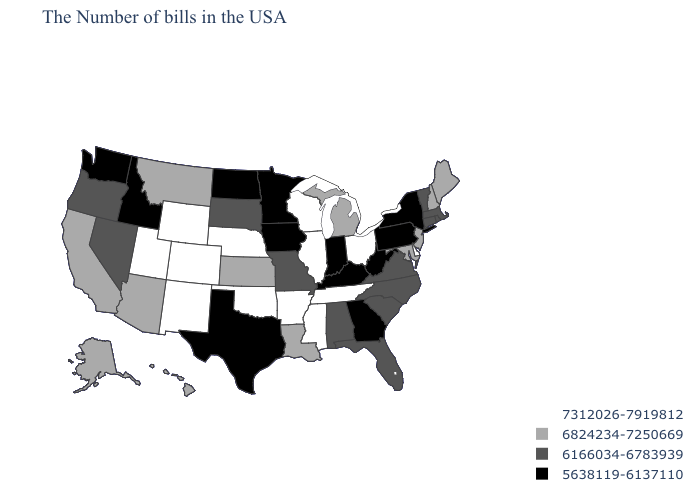What is the value of Kansas?
Short answer required. 6824234-7250669. Which states hav the highest value in the MidWest?
Write a very short answer. Ohio, Wisconsin, Illinois, Nebraska. Does Colorado have the highest value in the USA?
Keep it brief. Yes. Does Florida have the same value as New Jersey?
Keep it brief. No. What is the lowest value in the USA?
Quick response, please. 5638119-6137110. What is the highest value in the West ?
Quick response, please. 7312026-7919812. What is the highest value in the USA?
Quick response, please. 7312026-7919812. What is the value of South Dakota?
Give a very brief answer. 6166034-6783939. What is the value of Alabama?
Answer briefly. 6166034-6783939. Does Illinois have the highest value in the MidWest?
Give a very brief answer. Yes. Name the states that have a value in the range 6166034-6783939?
Give a very brief answer. Massachusetts, Rhode Island, Vermont, Connecticut, Virginia, North Carolina, South Carolina, Florida, Alabama, Missouri, South Dakota, Nevada, Oregon. What is the highest value in the West ?
Quick response, please. 7312026-7919812. Does Colorado have the same value as Missouri?
Answer briefly. No. What is the highest value in the Northeast ?
Keep it brief. 6824234-7250669. What is the value of California?
Give a very brief answer. 6824234-7250669. 